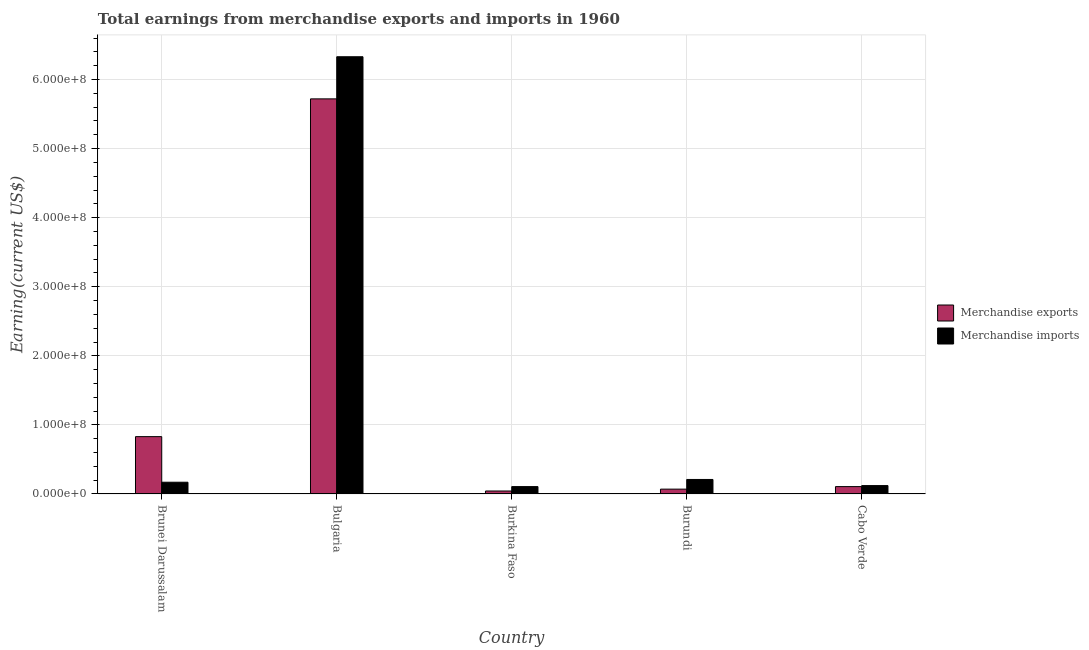How many different coloured bars are there?
Offer a terse response. 2. Are the number of bars per tick equal to the number of legend labels?
Ensure brevity in your answer.  Yes. What is the label of the 1st group of bars from the left?
Keep it short and to the point. Brunei Darussalam. What is the earnings from merchandise exports in Burundi?
Give a very brief answer. 7.00e+06. Across all countries, what is the maximum earnings from merchandise exports?
Offer a very short reply. 5.72e+08. Across all countries, what is the minimum earnings from merchandise imports?
Offer a very short reply. 1.07e+07. In which country was the earnings from merchandise exports minimum?
Provide a succinct answer. Burkina Faso. What is the total earnings from merchandise exports in the graph?
Make the answer very short. 6.77e+08. What is the difference between the earnings from merchandise exports in Brunei Darussalam and that in Cabo Verde?
Give a very brief answer. 7.23e+07. What is the difference between the earnings from merchandise exports in Brunei Darussalam and the earnings from merchandise imports in Bulgaria?
Offer a terse response. -5.50e+08. What is the average earnings from merchandise imports per country?
Your answer should be very brief. 1.39e+08. What is the difference between the earnings from merchandise exports and earnings from merchandise imports in Bulgaria?
Your response must be concise. -6.10e+07. In how many countries, is the earnings from merchandise imports greater than 20000000 US$?
Your answer should be very brief. 2. What is the ratio of the earnings from merchandise exports in Bulgaria to that in Burundi?
Give a very brief answer. 81.71. Is the earnings from merchandise imports in Bulgaria less than that in Cabo Verde?
Provide a short and direct response. No. What is the difference between the highest and the second highest earnings from merchandise exports?
Your answer should be very brief. 4.89e+08. What is the difference between the highest and the lowest earnings from merchandise exports?
Provide a succinct answer. 5.68e+08. In how many countries, is the earnings from merchandise exports greater than the average earnings from merchandise exports taken over all countries?
Your answer should be compact. 1. Is the sum of the earnings from merchandise imports in Bulgaria and Burundi greater than the maximum earnings from merchandise exports across all countries?
Give a very brief answer. Yes. How many bars are there?
Offer a very short reply. 10. How many countries are there in the graph?
Provide a succinct answer. 5. Are the values on the major ticks of Y-axis written in scientific E-notation?
Provide a short and direct response. Yes. Does the graph contain grids?
Provide a succinct answer. Yes. Where does the legend appear in the graph?
Your response must be concise. Center right. How many legend labels are there?
Keep it short and to the point. 2. How are the legend labels stacked?
Ensure brevity in your answer.  Vertical. What is the title of the graph?
Your answer should be very brief. Total earnings from merchandise exports and imports in 1960. What is the label or title of the X-axis?
Keep it short and to the point. Country. What is the label or title of the Y-axis?
Ensure brevity in your answer.  Earning(current US$). What is the Earning(current US$) in Merchandise exports in Brunei Darussalam?
Provide a short and direct response. 8.30e+07. What is the Earning(current US$) in Merchandise imports in Brunei Darussalam?
Your answer should be compact. 1.70e+07. What is the Earning(current US$) of Merchandise exports in Bulgaria?
Provide a short and direct response. 5.72e+08. What is the Earning(current US$) of Merchandise imports in Bulgaria?
Offer a terse response. 6.33e+08. What is the Earning(current US$) in Merchandise exports in Burkina Faso?
Provide a succinct answer. 4.31e+06. What is the Earning(current US$) of Merchandise imports in Burkina Faso?
Provide a succinct answer. 1.07e+07. What is the Earning(current US$) of Merchandise imports in Burundi?
Your answer should be very brief. 2.10e+07. What is the Earning(current US$) in Merchandise exports in Cabo Verde?
Offer a terse response. 1.07e+07. What is the Earning(current US$) of Merchandise imports in Cabo Verde?
Offer a very short reply. 1.21e+07. Across all countries, what is the maximum Earning(current US$) of Merchandise exports?
Your answer should be very brief. 5.72e+08. Across all countries, what is the maximum Earning(current US$) of Merchandise imports?
Offer a terse response. 6.33e+08. Across all countries, what is the minimum Earning(current US$) in Merchandise exports?
Your response must be concise. 4.31e+06. Across all countries, what is the minimum Earning(current US$) in Merchandise imports?
Provide a short and direct response. 1.07e+07. What is the total Earning(current US$) in Merchandise exports in the graph?
Your answer should be very brief. 6.77e+08. What is the total Earning(current US$) in Merchandise imports in the graph?
Keep it short and to the point. 6.94e+08. What is the difference between the Earning(current US$) in Merchandise exports in Brunei Darussalam and that in Bulgaria?
Offer a very short reply. -4.89e+08. What is the difference between the Earning(current US$) of Merchandise imports in Brunei Darussalam and that in Bulgaria?
Ensure brevity in your answer.  -6.16e+08. What is the difference between the Earning(current US$) in Merchandise exports in Brunei Darussalam and that in Burkina Faso?
Your answer should be very brief. 7.87e+07. What is the difference between the Earning(current US$) in Merchandise imports in Brunei Darussalam and that in Burkina Faso?
Your answer should be compact. 6.33e+06. What is the difference between the Earning(current US$) in Merchandise exports in Brunei Darussalam and that in Burundi?
Keep it short and to the point. 7.60e+07. What is the difference between the Earning(current US$) in Merchandise exports in Brunei Darussalam and that in Cabo Verde?
Give a very brief answer. 7.23e+07. What is the difference between the Earning(current US$) in Merchandise imports in Brunei Darussalam and that in Cabo Verde?
Give a very brief answer. 4.87e+06. What is the difference between the Earning(current US$) in Merchandise exports in Bulgaria and that in Burkina Faso?
Provide a succinct answer. 5.68e+08. What is the difference between the Earning(current US$) of Merchandise imports in Bulgaria and that in Burkina Faso?
Provide a succinct answer. 6.22e+08. What is the difference between the Earning(current US$) of Merchandise exports in Bulgaria and that in Burundi?
Offer a terse response. 5.65e+08. What is the difference between the Earning(current US$) of Merchandise imports in Bulgaria and that in Burundi?
Ensure brevity in your answer.  6.12e+08. What is the difference between the Earning(current US$) of Merchandise exports in Bulgaria and that in Cabo Verde?
Ensure brevity in your answer.  5.61e+08. What is the difference between the Earning(current US$) in Merchandise imports in Bulgaria and that in Cabo Verde?
Make the answer very short. 6.21e+08. What is the difference between the Earning(current US$) in Merchandise exports in Burkina Faso and that in Burundi?
Keep it short and to the point. -2.69e+06. What is the difference between the Earning(current US$) in Merchandise imports in Burkina Faso and that in Burundi?
Make the answer very short. -1.03e+07. What is the difference between the Earning(current US$) in Merchandise exports in Burkina Faso and that in Cabo Verde?
Offer a terse response. -6.35e+06. What is the difference between the Earning(current US$) in Merchandise imports in Burkina Faso and that in Cabo Verde?
Provide a succinct answer. -1.47e+06. What is the difference between the Earning(current US$) in Merchandise exports in Burundi and that in Cabo Verde?
Provide a short and direct response. -3.66e+06. What is the difference between the Earning(current US$) in Merchandise imports in Burundi and that in Cabo Verde?
Your answer should be very brief. 8.87e+06. What is the difference between the Earning(current US$) in Merchandise exports in Brunei Darussalam and the Earning(current US$) in Merchandise imports in Bulgaria?
Your answer should be compact. -5.50e+08. What is the difference between the Earning(current US$) in Merchandise exports in Brunei Darussalam and the Earning(current US$) in Merchandise imports in Burkina Faso?
Offer a terse response. 7.23e+07. What is the difference between the Earning(current US$) in Merchandise exports in Brunei Darussalam and the Earning(current US$) in Merchandise imports in Burundi?
Offer a terse response. 6.20e+07. What is the difference between the Earning(current US$) in Merchandise exports in Brunei Darussalam and the Earning(current US$) in Merchandise imports in Cabo Verde?
Ensure brevity in your answer.  7.09e+07. What is the difference between the Earning(current US$) in Merchandise exports in Bulgaria and the Earning(current US$) in Merchandise imports in Burkina Faso?
Offer a terse response. 5.61e+08. What is the difference between the Earning(current US$) of Merchandise exports in Bulgaria and the Earning(current US$) of Merchandise imports in Burundi?
Keep it short and to the point. 5.51e+08. What is the difference between the Earning(current US$) of Merchandise exports in Bulgaria and the Earning(current US$) of Merchandise imports in Cabo Verde?
Provide a succinct answer. 5.60e+08. What is the difference between the Earning(current US$) of Merchandise exports in Burkina Faso and the Earning(current US$) of Merchandise imports in Burundi?
Give a very brief answer. -1.67e+07. What is the difference between the Earning(current US$) in Merchandise exports in Burkina Faso and the Earning(current US$) in Merchandise imports in Cabo Verde?
Your response must be concise. -7.82e+06. What is the difference between the Earning(current US$) in Merchandise exports in Burundi and the Earning(current US$) in Merchandise imports in Cabo Verde?
Make the answer very short. -5.13e+06. What is the average Earning(current US$) in Merchandise exports per country?
Make the answer very short. 1.35e+08. What is the average Earning(current US$) of Merchandise imports per country?
Offer a very short reply. 1.39e+08. What is the difference between the Earning(current US$) in Merchandise exports and Earning(current US$) in Merchandise imports in Brunei Darussalam?
Make the answer very short. 6.60e+07. What is the difference between the Earning(current US$) of Merchandise exports and Earning(current US$) of Merchandise imports in Bulgaria?
Offer a very short reply. -6.10e+07. What is the difference between the Earning(current US$) of Merchandise exports and Earning(current US$) of Merchandise imports in Burkina Faso?
Offer a very short reply. -6.36e+06. What is the difference between the Earning(current US$) in Merchandise exports and Earning(current US$) in Merchandise imports in Burundi?
Keep it short and to the point. -1.40e+07. What is the difference between the Earning(current US$) in Merchandise exports and Earning(current US$) in Merchandise imports in Cabo Verde?
Offer a terse response. -1.47e+06. What is the ratio of the Earning(current US$) of Merchandise exports in Brunei Darussalam to that in Bulgaria?
Give a very brief answer. 0.15. What is the ratio of the Earning(current US$) of Merchandise imports in Brunei Darussalam to that in Bulgaria?
Offer a terse response. 0.03. What is the ratio of the Earning(current US$) of Merchandise exports in Brunei Darussalam to that in Burkina Faso?
Keep it short and to the point. 19.26. What is the ratio of the Earning(current US$) in Merchandise imports in Brunei Darussalam to that in Burkina Faso?
Provide a short and direct response. 1.59. What is the ratio of the Earning(current US$) in Merchandise exports in Brunei Darussalam to that in Burundi?
Provide a succinct answer. 11.86. What is the ratio of the Earning(current US$) of Merchandise imports in Brunei Darussalam to that in Burundi?
Provide a succinct answer. 0.81. What is the ratio of the Earning(current US$) in Merchandise exports in Brunei Darussalam to that in Cabo Verde?
Make the answer very short. 7.79. What is the ratio of the Earning(current US$) of Merchandise imports in Brunei Darussalam to that in Cabo Verde?
Offer a very short reply. 1.4. What is the ratio of the Earning(current US$) of Merchandise exports in Bulgaria to that in Burkina Faso?
Make the answer very short. 132.71. What is the ratio of the Earning(current US$) in Merchandise imports in Bulgaria to that in Burkina Faso?
Offer a terse response. 59.35. What is the ratio of the Earning(current US$) in Merchandise exports in Bulgaria to that in Burundi?
Your response must be concise. 81.71. What is the ratio of the Earning(current US$) of Merchandise imports in Bulgaria to that in Burundi?
Keep it short and to the point. 30.14. What is the ratio of the Earning(current US$) of Merchandise exports in Bulgaria to that in Cabo Verde?
Keep it short and to the point. 53.66. What is the ratio of the Earning(current US$) in Merchandise imports in Bulgaria to that in Cabo Verde?
Your answer should be very brief. 52.18. What is the ratio of the Earning(current US$) in Merchandise exports in Burkina Faso to that in Burundi?
Ensure brevity in your answer.  0.62. What is the ratio of the Earning(current US$) in Merchandise imports in Burkina Faso to that in Burundi?
Make the answer very short. 0.51. What is the ratio of the Earning(current US$) in Merchandise exports in Burkina Faso to that in Cabo Verde?
Offer a terse response. 0.4. What is the ratio of the Earning(current US$) of Merchandise imports in Burkina Faso to that in Cabo Verde?
Your answer should be compact. 0.88. What is the ratio of the Earning(current US$) of Merchandise exports in Burundi to that in Cabo Verde?
Provide a succinct answer. 0.66. What is the ratio of the Earning(current US$) in Merchandise imports in Burundi to that in Cabo Verde?
Provide a succinct answer. 1.73. What is the difference between the highest and the second highest Earning(current US$) in Merchandise exports?
Provide a short and direct response. 4.89e+08. What is the difference between the highest and the second highest Earning(current US$) in Merchandise imports?
Your answer should be compact. 6.12e+08. What is the difference between the highest and the lowest Earning(current US$) of Merchandise exports?
Offer a terse response. 5.68e+08. What is the difference between the highest and the lowest Earning(current US$) of Merchandise imports?
Provide a short and direct response. 6.22e+08. 